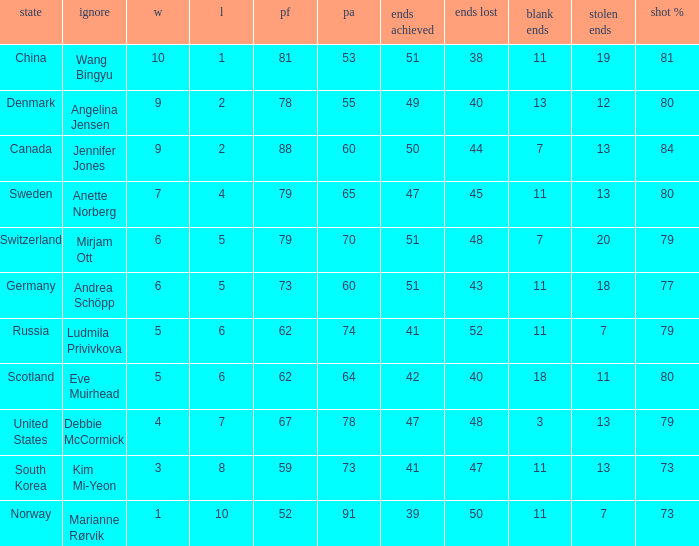What is the minimum Wins a team has? 1.0. 